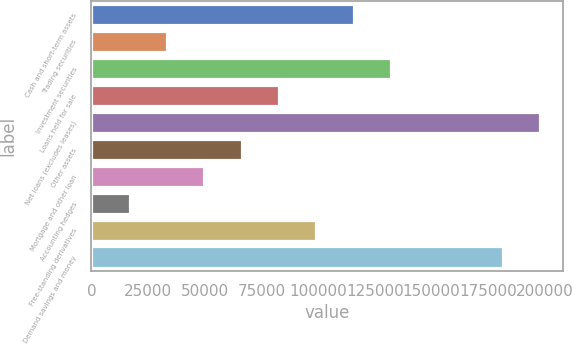Convert chart. <chart><loc_0><loc_0><loc_500><loc_500><bar_chart><fcel>Cash and short-term assets<fcel>Trading securities<fcel>Investment securities<fcel>Loans held for sale<fcel>Net loans (excludes leases)<fcel>Other assets<fcel>Mortgage and other loan<fcel>Accounting hedges<fcel>Free-standing derivatives<fcel>Demand savings and money<nl><fcel>115680<fcel>33292.8<fcel>132157<fcel>82725<fcel>198067<fcel>66247.6<fcel>49770.2<fcel>16815.4<fcel>99202.4<fcel>181589<nl></chart> 